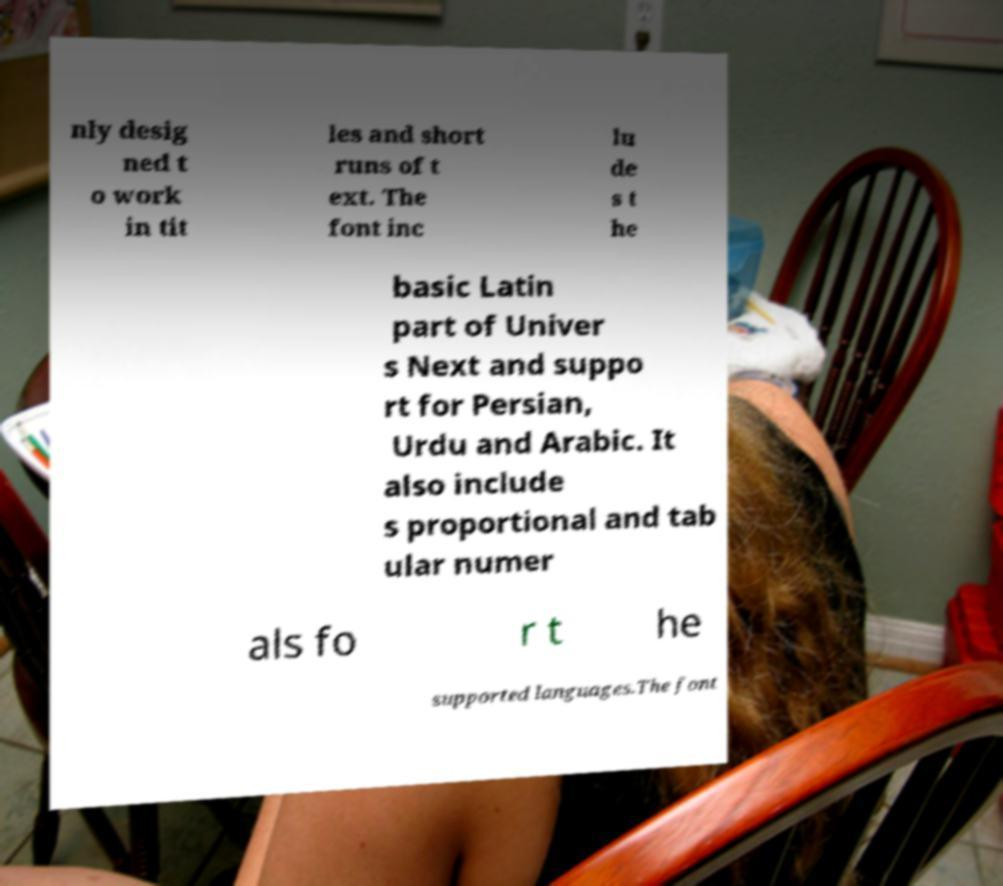Please read and relay the text visible in this image. What does it say? nly desig ned t o work in tit les and short runs of t ext. The font inc lu de s t he basic Latin part of Univer s Next and suppo rt for Persian, Urdu and Arabic. It also include s proportional and tab ular numer als fo r t he supported languages.The font 